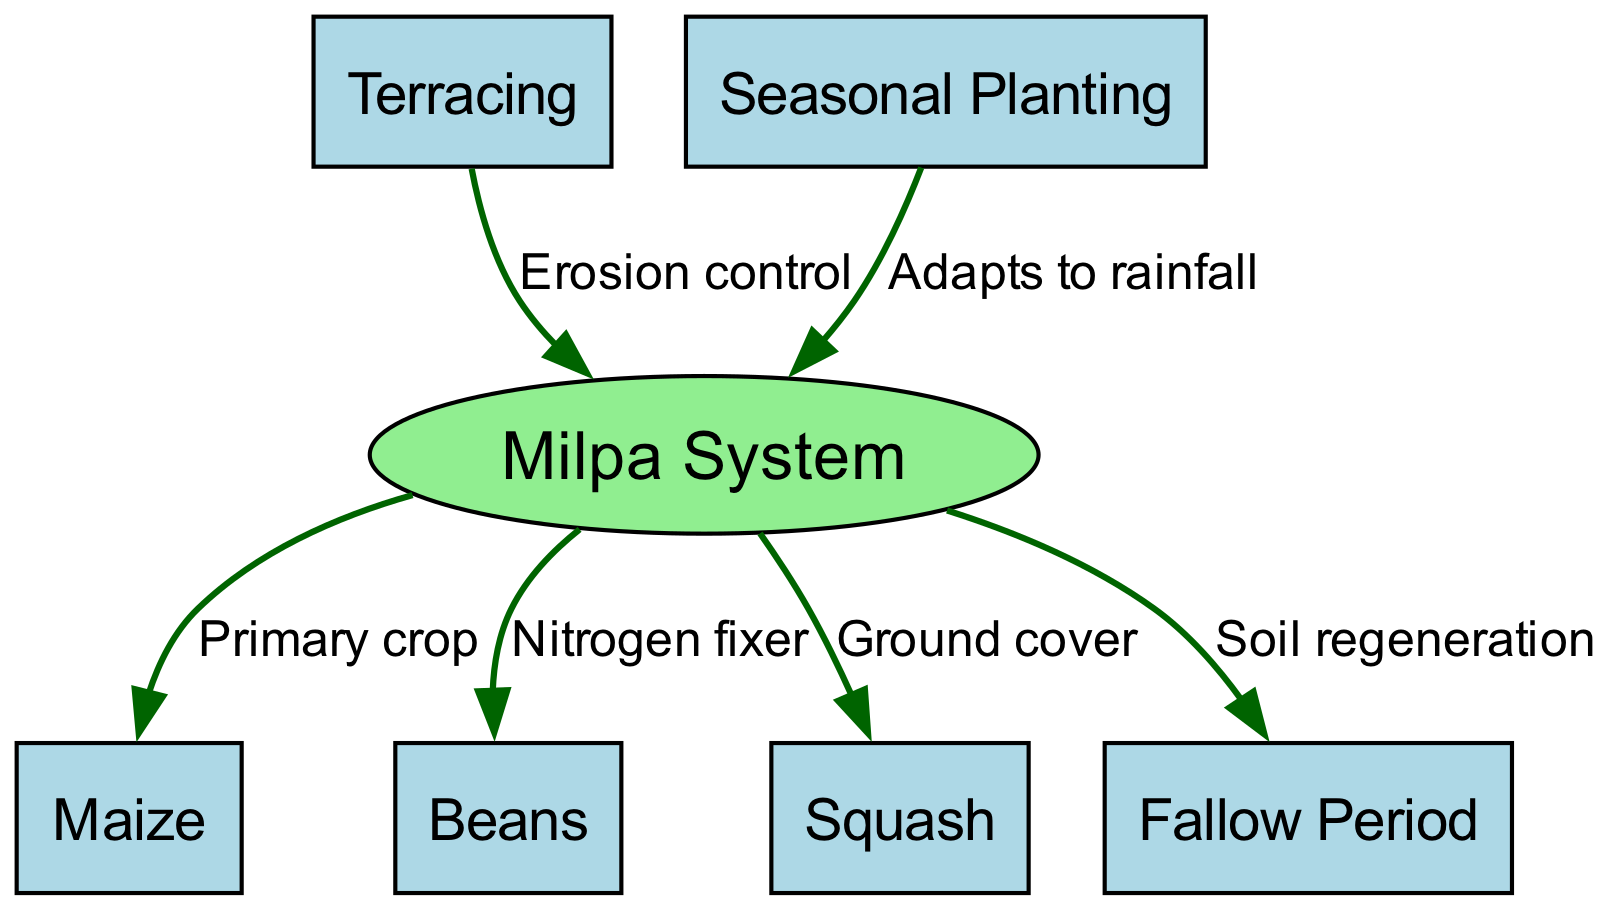What is the primary crop in the Milpa system? The diagram indicates that the "Milpa System" has the "Maize" as its primary crop, shown by the directed edge labeled "Primary crop" from node 1 (Milpa System) to node 2 (Maize).
Answer: Maize How many crops are included in the Milpa System? By counting the nodes connected to the "Milpa System" (node 1), there are three crops: "Maize," "Beans," and "Squash," making a total of three crops connected directly to the Milpa system.
Answer: Three What is the function of beans in the Milpa System? The diagram labels the beans as a "Nitrogen fixer," indicating their role in improving soil fertility, which is represented by the edge from node 1 (Milpa System) to node 3 (Beans).
Answer: Nitrogen fixer What does the fallow period contribute to in the agricultural cycle? According to the diagram, the fallow period is connected to the Milpa System with a label "Soil regeneration," which suggests its role is to restore nutrients and overall soil health after cultivation.
Answer: Soil regeneration How does terracing support the Milpa System? The diagram shows that terracing, represented by node 6, connects to the Milpa System with the label "Erosion control," indicating that it helps prevent soil erosion which is vital for sustainable agriculture.
Answer: Erosion control What does seasonal planting allow for in the Milpa System? The edge indicates that the "Seasonal Planting" connected to the Milpa System enables adaptation to rainfall, represented by the label "Adapts to rainfall," showing its importance in managing crop cycles effectively.
Answer: Adapts to rainfall Which crop acts as ground cover in the Milpa System? The diagram directly connects "Squash" to the "Milpa System" with the edge labeled "Ground cover," which indicates its role in preventing weed growth and managing moisture.
Answer: Squash What is the total number of edges in the diagram? By counting all the connections (edges) depicted in the diagram, we can identify there are six edges in total, facilitating connections between nodes.
Answer: Six 